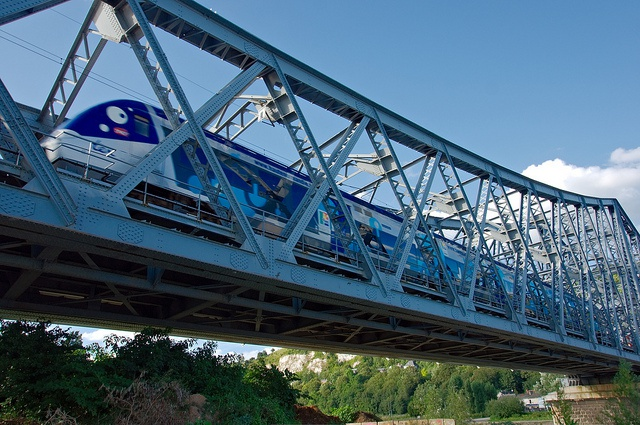Describe the objects in this image and their specific colors. I can see a train in blue, navy, and gray tones in this image. 